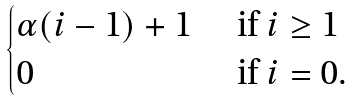Convert formula to latex. <formula><loc_0><loc_0><loc_500><loc_500>\begin{cases} \alpha ( i - 1 ) + 1 & \text { if } i \geq 1 \\ 0 & \text { if } i = 0 . \end{cases}</formula> 